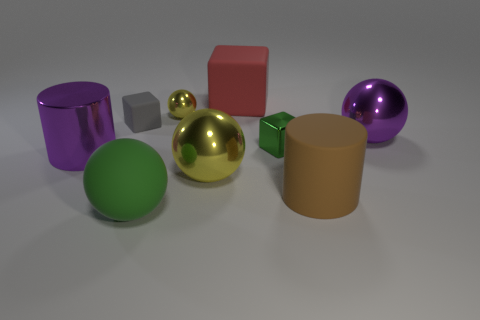Are there the same number of shiny cubes in front of the brown matte thing and gray cubes that are behind the small shiny ball?
Keep it short and to the point. Yes. What material is the brown cylinder?
Your response must be concise. Rubber. There is a green object left of the red cube; what material is it?
Provide a succinct answer. Rubber. Are there more green spheres that are behind the big red matte object than large matte cubes?
Your answer should be very brief. No. There is a yellow ball that is behind the large cylinder left of the green sphere; is there a large red block in front of it?
Your response must be concise. No. Are there any big green rubber objects left of the tiny gray cube?
Ensure brevity in your answer.  No. How many big rubber cylinders have the same color as the large block?
Your answer should be very brief. 0. There is a brown cylinder that is the same material as the large green ball; what size is it?
Your answer should be very brief. Large. What is the size of the purple cylinder that is in front of the metallic thing to the right of the cylinder that is right of the red object?
Your answer should be very brief. Large. What is the size of the cylinder that is right of the large green thing?
Your answer should be compact. Large. 